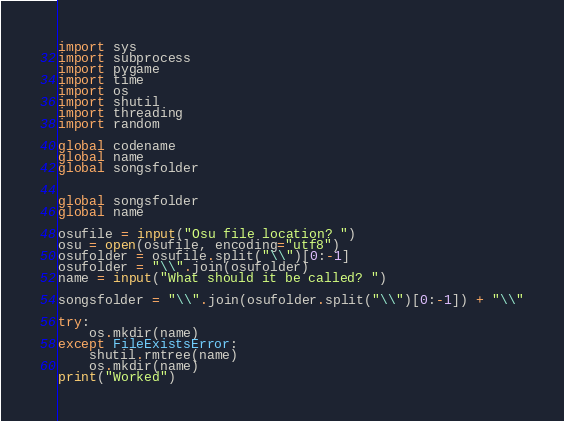<code> <loc_0><loc_0><loc_500><loc_500><_Python_>import sys
import subprocess
import pygame
import time
import os
import shutil
import threading
import random

global codename
global name
global songsfolder


global songsfolder
global name

osufile = input("Osu file location? ")
osu = open(osufile, encoding="utf8")
osufolder = osufile.split("\\")[0:-1]
osufolder = "\\".join(osufolder)
name = input("What should it be called? ")

songsfolder = "\\".join(osufolder.split("\\")[0:-1]) + "\\"

try:
    os.mkdir(name)
except FileExistsError:
    shutil.rmtree(name)
    os.mkdir(name)
print("Worked")</code> 